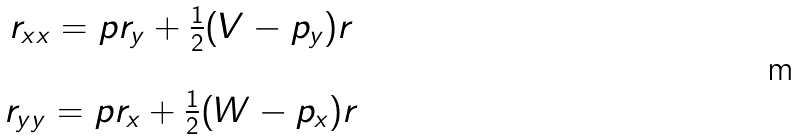<formula> <loc_0><loc_0><loc_500><loc_500>\begin{array} { c } r _ { x x } = p r _ { y } + \frac { 1 } { 2 } ( V - p _ { y } ) r \\ \\ r _ { y y } = p r _ { x } + \frac { 1 } { 2 } ( W - p _ { x } ) r \\ \end{array}</formula> 